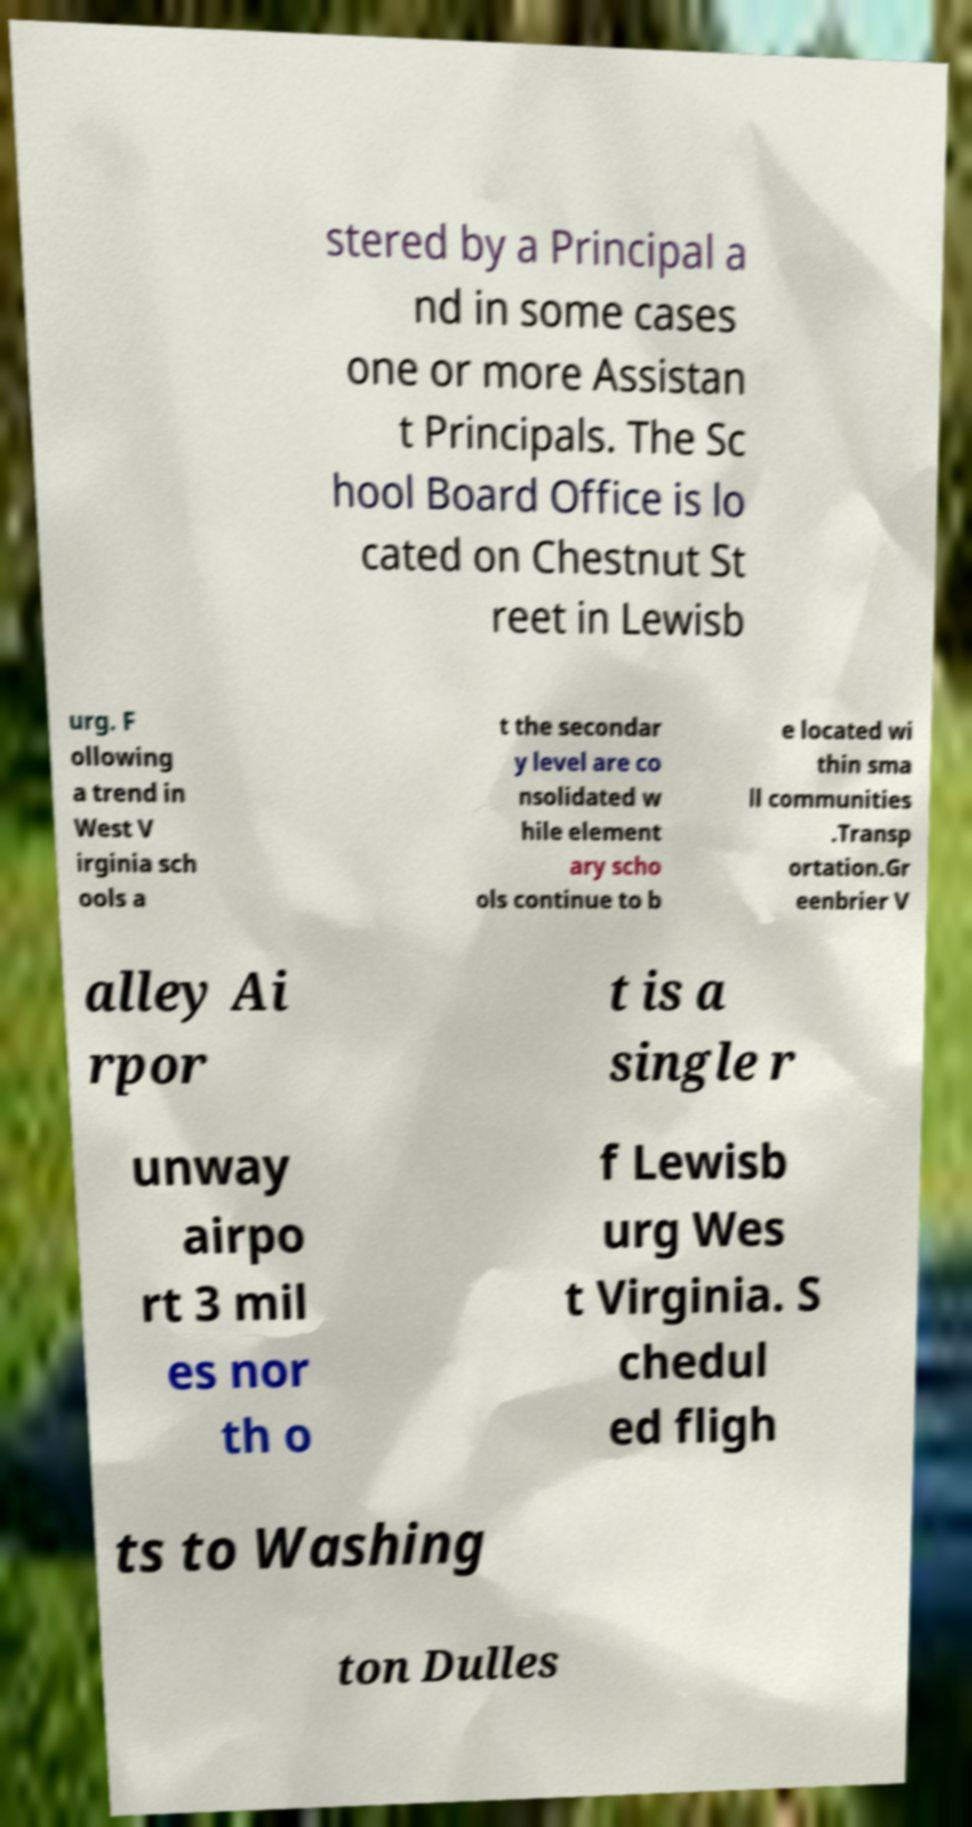There's text embedded in this image that I need extracted. Can you transcribe it verbatim? stered by a Principal a nd in some cases one or more Assistan t Principals. The Sc hool Board Office is lo cated on Chestnut St reet in Lewisb urg. F ollowing a trend in West V irginia sch ools a t the secondar y level are co nsolidated w hile element ary scho ols continue to b e located wi thin sma ll communities .Transp ortation.Gr eenbrier V alley Ai rpor t is a single r unway airpo rt 3 mil es nor th o f Lewisb urg Wes t Virginia. S chedul ed fligh ts to Washing ton Dulles 